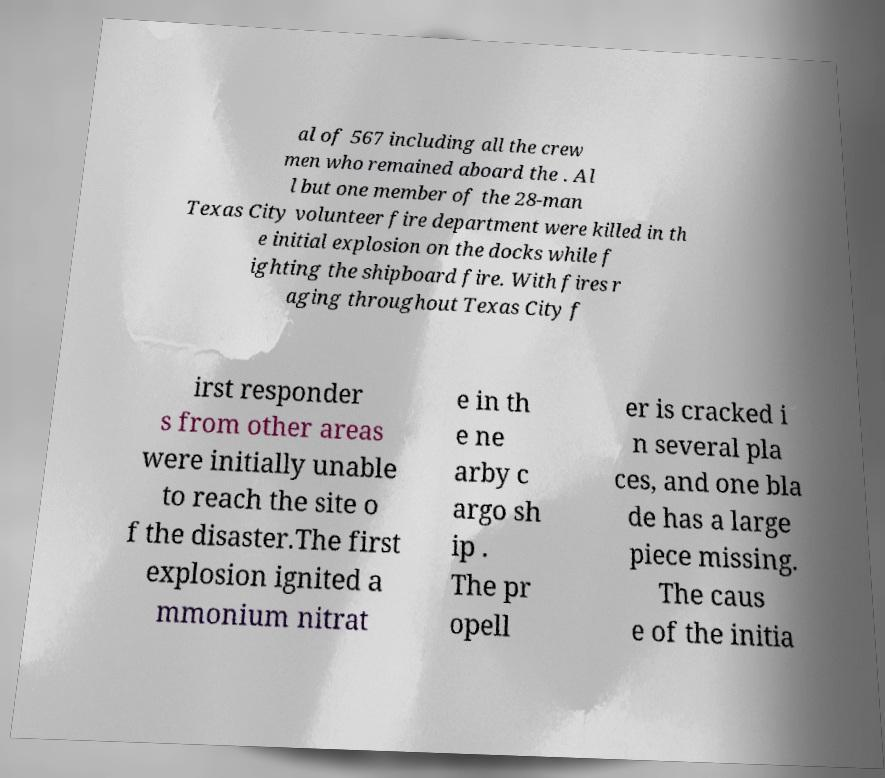Can you read and provide the text displayed in the image?This photo seems to have some interesting text. Can you extract and type it out for me? al of 567 including all the crew men who remained aboard the . Al l but one member of the 28-man Texas City volunteer fire department were killed in th e initial explosion on the docks while f ighting the shipboard fire. With fires r aging throughout Texas City f irst responder s from other areas were initially unable to reach the site o f the disaster.The first explosion ignited a mmonium nitrat e in th e ne arby c argo sh ip . The pr opell er is cracked i n several pla ces, and one bla de has a large piece missing. The caus e of the initia 